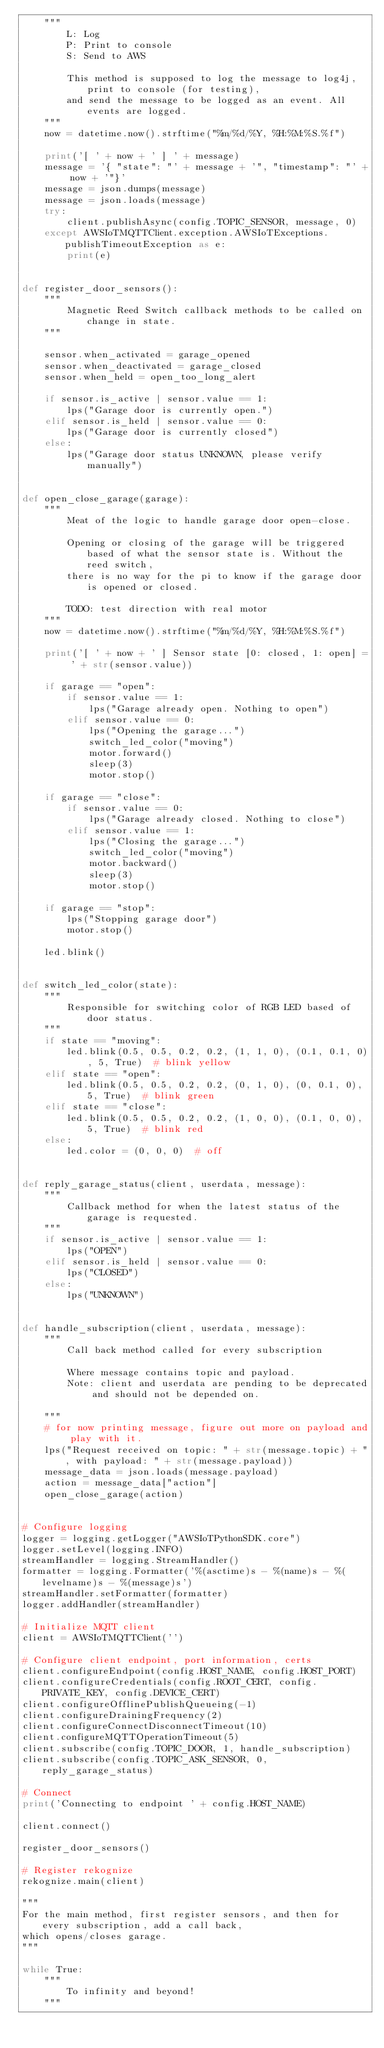Convert code to text. <code><loc_0><loc_0><loc_500><loc_500><_Python_>    """
        L: Log
        P: Print to console
        S: Send to AWS

        This method is supposed to log the message to log4j, print to console (for testing),
        and send the message to be logged as an event. All events are logged.
    """
    now = datetime.now().strftime("%m/%d/%Y, %H:%M:%S.%f")

    print('[ ' + now + ' ] ' + message)
    message = '{ "state": "' + message + '", "timestamp": "' + now + '"}'
    message = json.dumps(message)
    message = json.loads(message)
    try:
        client.publishAsync(config.TOPIC_SENSOR, message, 0)
    except AWSIoTMQTTClient.exception.AWSIoTExceptions.publishTimeoutException as e:
        print(e)


def register_door_sensors():
    """
        Magnetic Reed Switch callback methods to be called on change in state.
    """

    sensor.when_activated = garage_opened
    sensor.when_deactivated = garage_closed
    sensor.when_held = open_too_long_alert

    if sensor.is_active | sensor.value == 1:
        lps("Garage door is currently open.")
    elif sensor.is_held | sensor.value == 0:
        lps("Garage door is currently closed")
    else:
        lps("Garage door status UNKNOWN, please verify manually")


def open_close_garage(garage):
    """
        Meat of the logic to handle garage door open-close.

        Opening or closing of the garage will be triggered based of what the sensor state is. Without the reed switch,
        there is no way for the pi to know if the garage door is opened or closed.

        TODO: test direction with real motor
    """
    now = datetime.now().strftime("%m/%d/%Y, %H:%M:%S.%f")

    print('[ ' + now + ' ] Sensor state [0: closed, 1: open] = ' + str(sensor.value))

    if garage == "open":
        if sensor.value == 1:
            lps("Garage already open. Nothing to open")
        elif sensor.value == 0:
            lps("Opening the garage...")
            switch_led_color("moving")
            motor.forward()
            sleep(3)
            motor.stop()

    if garage == "close":
        if sensor.value == 0:
            lps("Garage already closed. Nothing to close")
        elif sensor.value == 1:
            lps("Closing the garage...")
            switch_led_color("moving")
            motor.backward()
            sleep(3)
            motor.stop()

    if garage == "stop":
        lps("Stopping garage door")
        motor.stop()

    led.blink()


def switch_led_color(state):
    """
        Responsible for switching color of RGB LED based of door status.
    """
    if state == "moving":
        led.blink(0.5, 0.5, 0.2, 0.2, (1, 1, 0), (0.1, 0.1, 0), 5, True)  # blink yellow
    elif state == "open":
        led.blink(0.5, 0.5, 0.2, 0.2, (0, 1, 0), (0, 0.1, 0), 5, True)  # blink green
    elif state == "close":
        led.blink(0.5, 0.5, 0.2, 0.2, (1, 0, 0), (0.1, 0, 0), 5, True)  # blink red
    else:
        led.color = (0, 0, 0)  # off


def reply_garage_status(client, userdata, message):
    """
        Callback method for when the latest status of the garage is requested.
    """
    if sensor.is_active | sensor.value == 1:
        lps("OPEN")
    elif sensor.is_held | sensor.value == 0:
        lps("CLOSED")
    else:
        lps("UNKNOWN")


def handle_subscription(client, userdata, message):
    """
        Call back method called for every subscription

        Where message contains topic and payload.
        Note: client and userdata are pending to be deprecated and should not be depended on.

    """
    # for now printing message, figure out more on payload and play with it.
    lps("Request received on topic: " + str(message.topic) + ", with payload: " + str(message.payload))
    message_data = json.loads(message.payload)
    action = message_data["action"]
    open_close_garage(action)


# Configure logging
logger = logging.getLogger("AWSIoTPythonSDK.core")
logger.setLevel(logging.INFO)
streamHandler = logging.StreamHandler()
formatter = logging.Formatter('%(asctime)s - %(name)s - %(levelname)s - %(message)s')
streamHandler.setFormatter(formatter)
logger.addHandler(streamHandler)

# Initialize MQTT client
client = AWSIoTMQTTClient('')

# Configure client endpoint, port information, certs
client.configureEndpoint(config.HOST_NAME, config.HOST_PORT)
client.configureCredentials(config.ROOT_CERT, config.PRIVATE_KEY, config.DEVICE_CERT)
client.configureOfflinePublishQueueing(-1)
client.configureDrainingFrequency(2)
client.configureConnectDisconnectTimeout(10)
client.configureMQTTOperationTimeout(5)
client.subscribe(config.TOPIC_DOOR, 1, handle_subscription)
client.subscribe(config.TOPIC_ASK_SENSOR, 0, reply_garage_status)

# Connect
print('Connecting to endpoint ' + config.HOST_NAME)

client.connect()

register_door_sensors()

# Register rekognize
rekognize.main(client)

"""
For the main method, first register sensors, and then for every subscription, add a call back,
which opens/closes garage.
"""

while True:
    """
        To infinity and beyond!
    """
</code> 